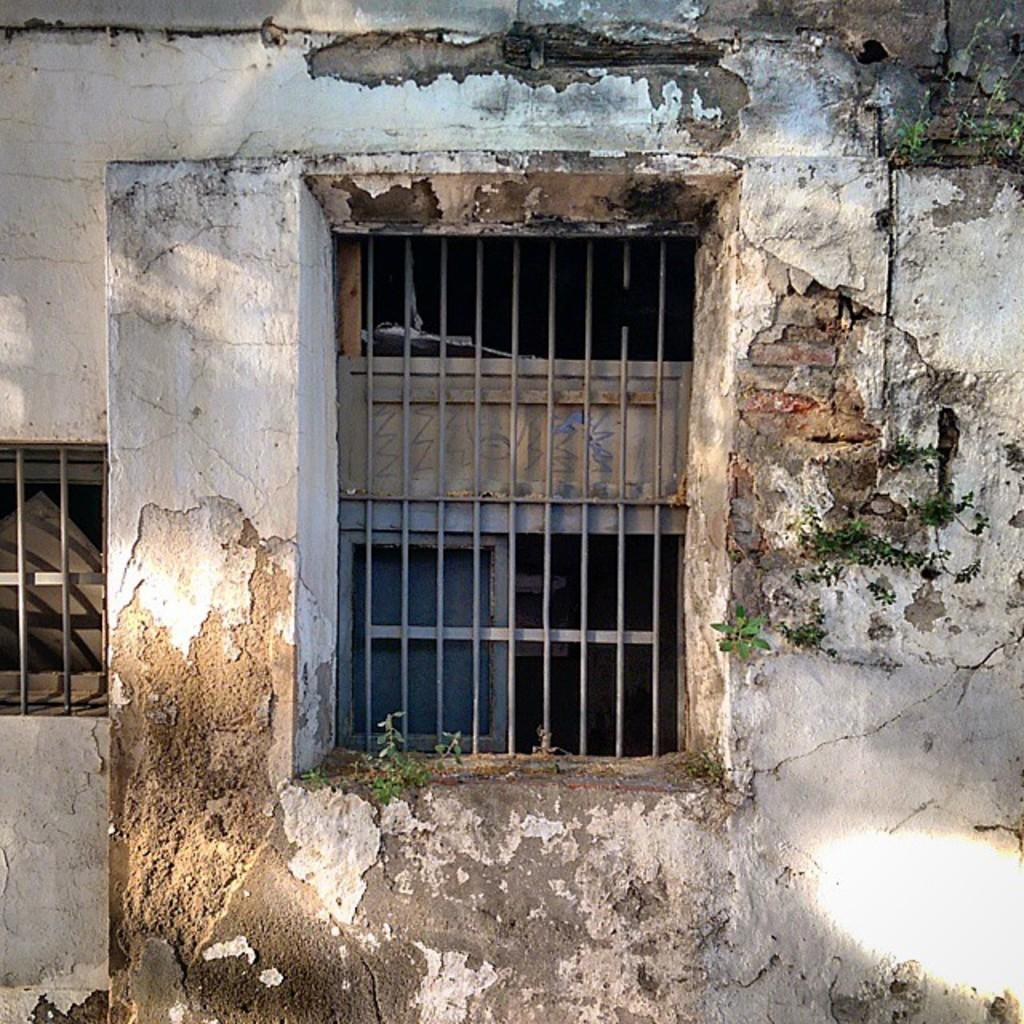What is the condition of the building in the image? The building in the image is damaged. Can you describe any specific features of the damaged building? The damaged building has a window. Who is the creator of the tub in the image? There is no tub present in the image. Is there a baseball game happening in the image? There is no indication of a baseball game or any sports activity in the image. 